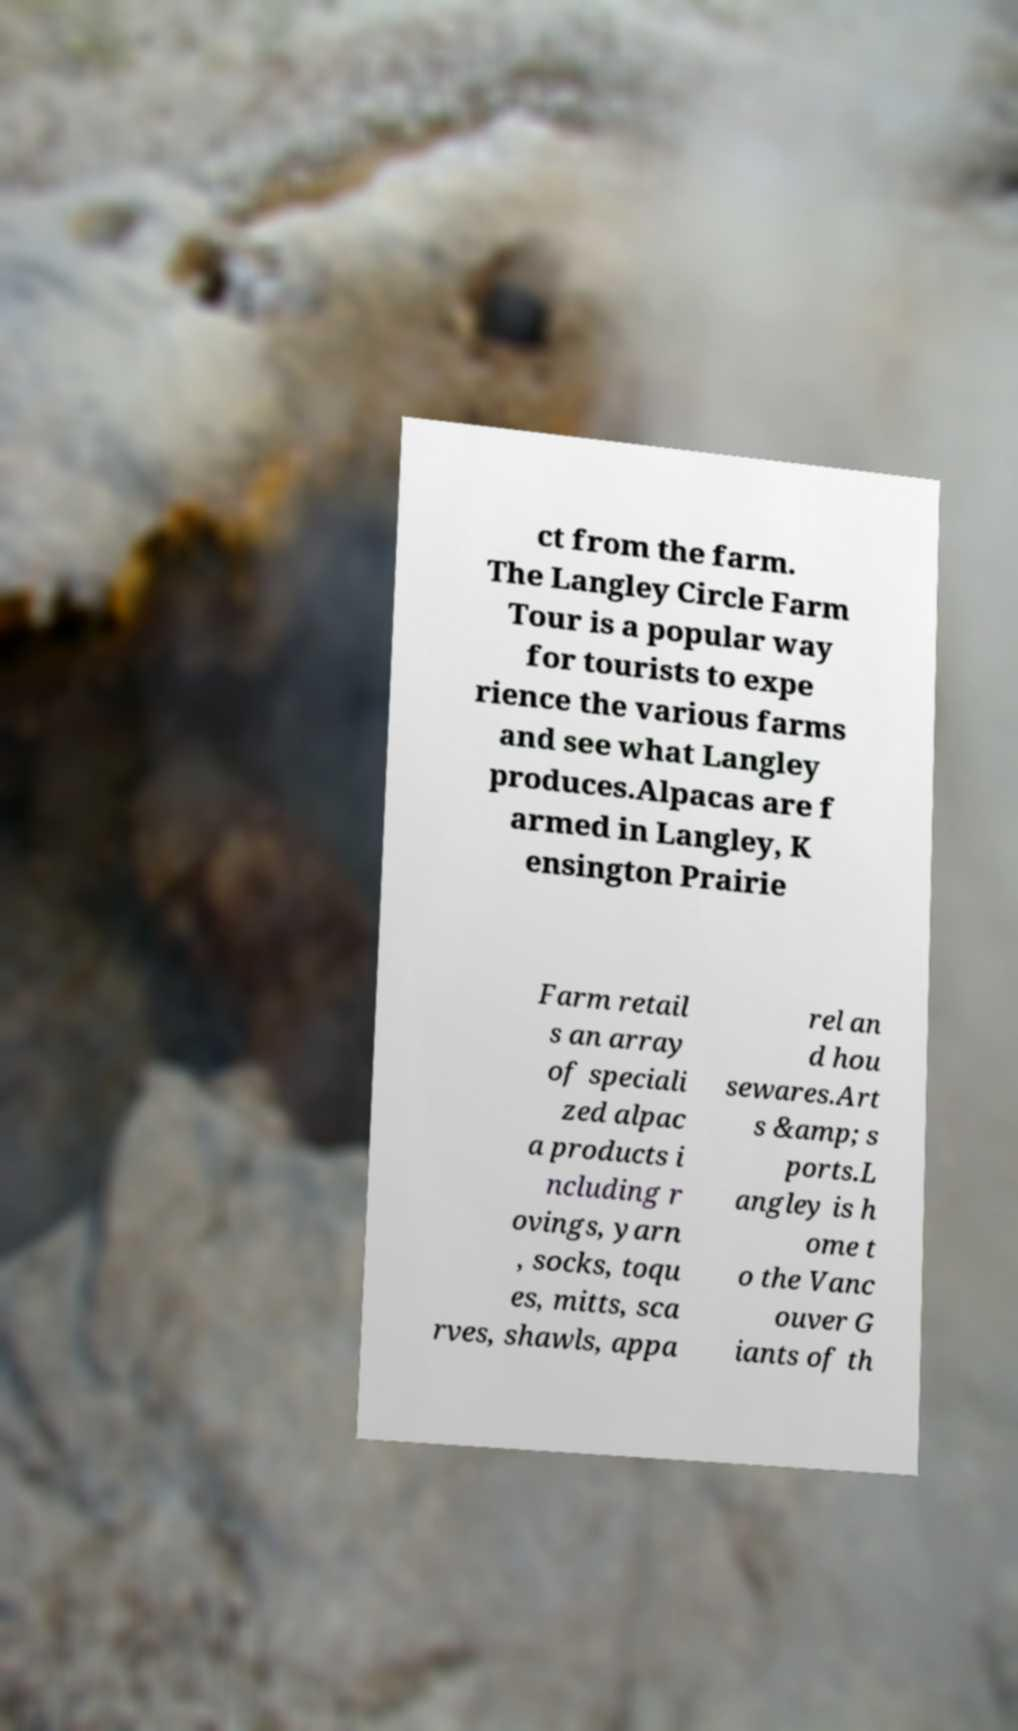Could you assist in decoding the text presented in this image and type it out clearly? ct from the farm. The Langley Circle Farm Tour is a popular way for tourists to expe rience the various farms and see what Langley produces.Alpacas are f armed in Langley, K ensington Prairie Farm retail s an array of speciali zed alpac a products i ncluding r ovings, yarn , socks, toqu es, mitts, sca rves, shawls, appa rel an d hou sewares.Art s &amp; s ports.L angley is h ome t o the Vanc ouver G iants of th 